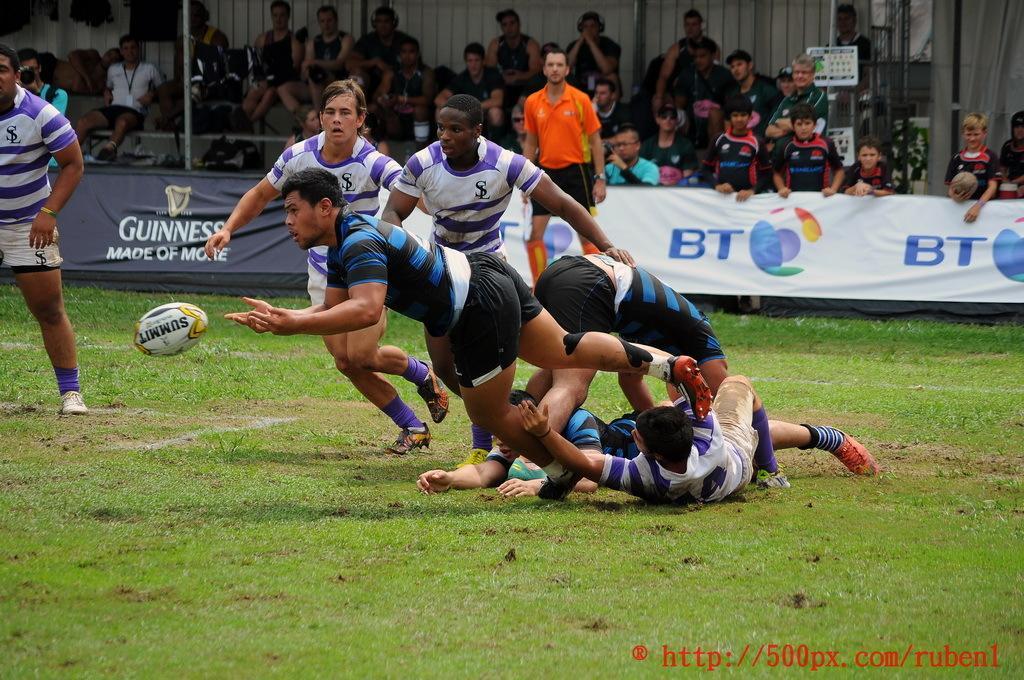Could you give a brief overview of what you see in this image? In the foreground of the picture I can see a few men playing the rugby game on the ground. In the background, I can see the spectators sitting on the chairs and a few of them standing and watching the game. I can see a man holding the camera. 